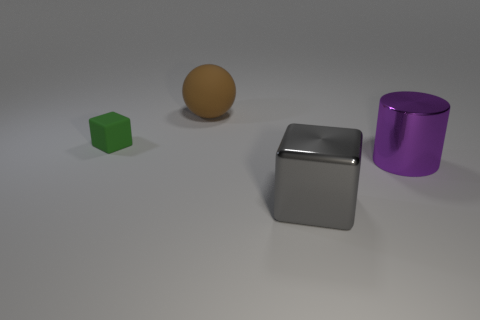There is a gray thing that is the same size as the matte sphere; what shape is it?
Your response must be concise. Cube. Is the object behind the small green rubber thing made of the same material as the block right of the large brown matte thing?
Make the answer very short. No. How many big purple things are there?
Give a very brief answer. 1. What number of green objects have the same shape as the large gray thing?
Give a very brief answer. 1. Is the big gray metallic thing the same shape as the tiny matte object?
Keep it short and to the point. Yes. What is the size of the purple shiny cylinder?
Offer a very short reply. Large. How many green objects are the same size as the brown ball?
Your answer should be very brief. 0. Is the size of the brown rubber object behind the small green thing the same as the block to the right of the brown ball?
Offer a terse response. Yes. The metal thing on the right side of the gray block has what shape?
Offer a very short reply. Cylinder. What material is the large thing behind the cube that is on the left side of the big brown rubber sphere?
Your answer should be compact. Rubber. 